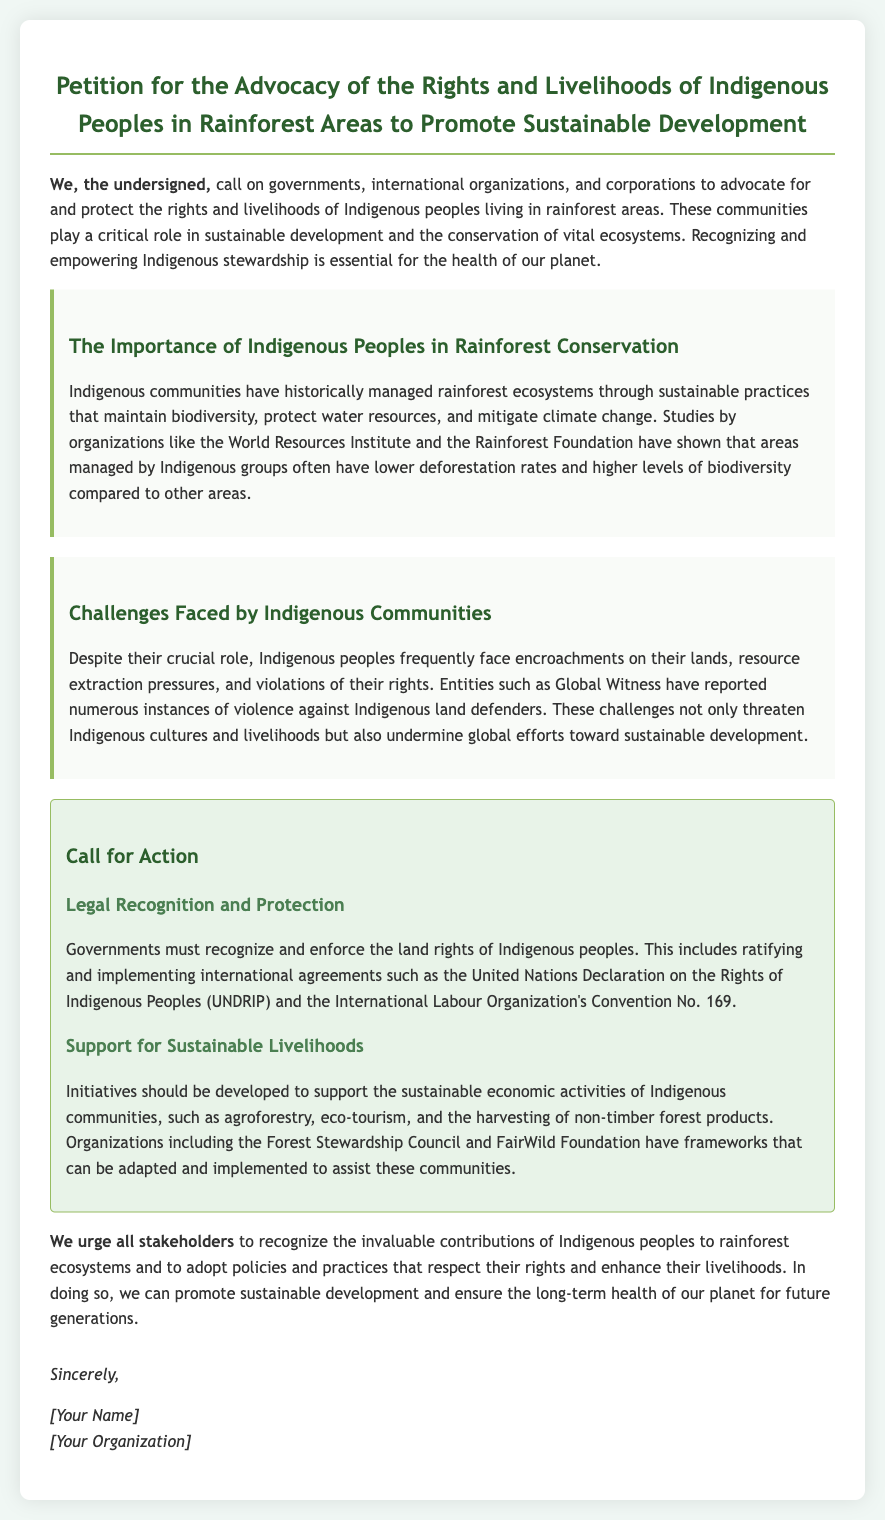What is the title of the petition? The title is found at the top of the document, highlighting the main purpose of the petition.
Answer: Petition for the Advocacy of the Rights and Livelihoods of Indigenous Peoples in Rainforest Areas to Promote Sustainable Development Who are the primary stakeholders called upon in the petition? The stakeholders mentioned are listed in the introductory sentence, indicating those the petition addresses.
Answer: governments, international organizations, corporations What international agreement is mentioned for land rights recognition? The document refers to specific international agreements that support Indigenous rights in the call for action section.
Answer: United Nations Declaration on the Rights of Indigenous Peoples (UNDRIP) What organization reported violence against Indigenous land defenders? This information is included in the section discussing challenges faced by Indigenous communities, citing specific entities involved in advocacy.
Answer: Global Witness What types of sustainable economic activities are supported for Indigenous communities? The sustainable activities are outlined in the section on support for sustainable livelihoods, providing examples of what is encouraged.
Answer: agroforestry, eco-tourism, harvesting non-timber forest products How does the petition suggest addressing global efforts toward sustainable development? The reasoning correlates the threats to Indigenous rights with the broader implications for sustainability, implying a direct relationship in the document.
Answer: By recognizing the contributions of Indigenous peoples What color code is primarily used for section headings in the document? This aspect relates to the visual design of the document, specifically indicating the aesthetic choices made by the author.
Answer: #2c5f2d What is the purpose of the petition? The purpose is clearly stated in the opening paragraph, summarizing the goals of the signatories.
Answer: Advocate for and protect the rights and livelihoods of Indigenous peoples 